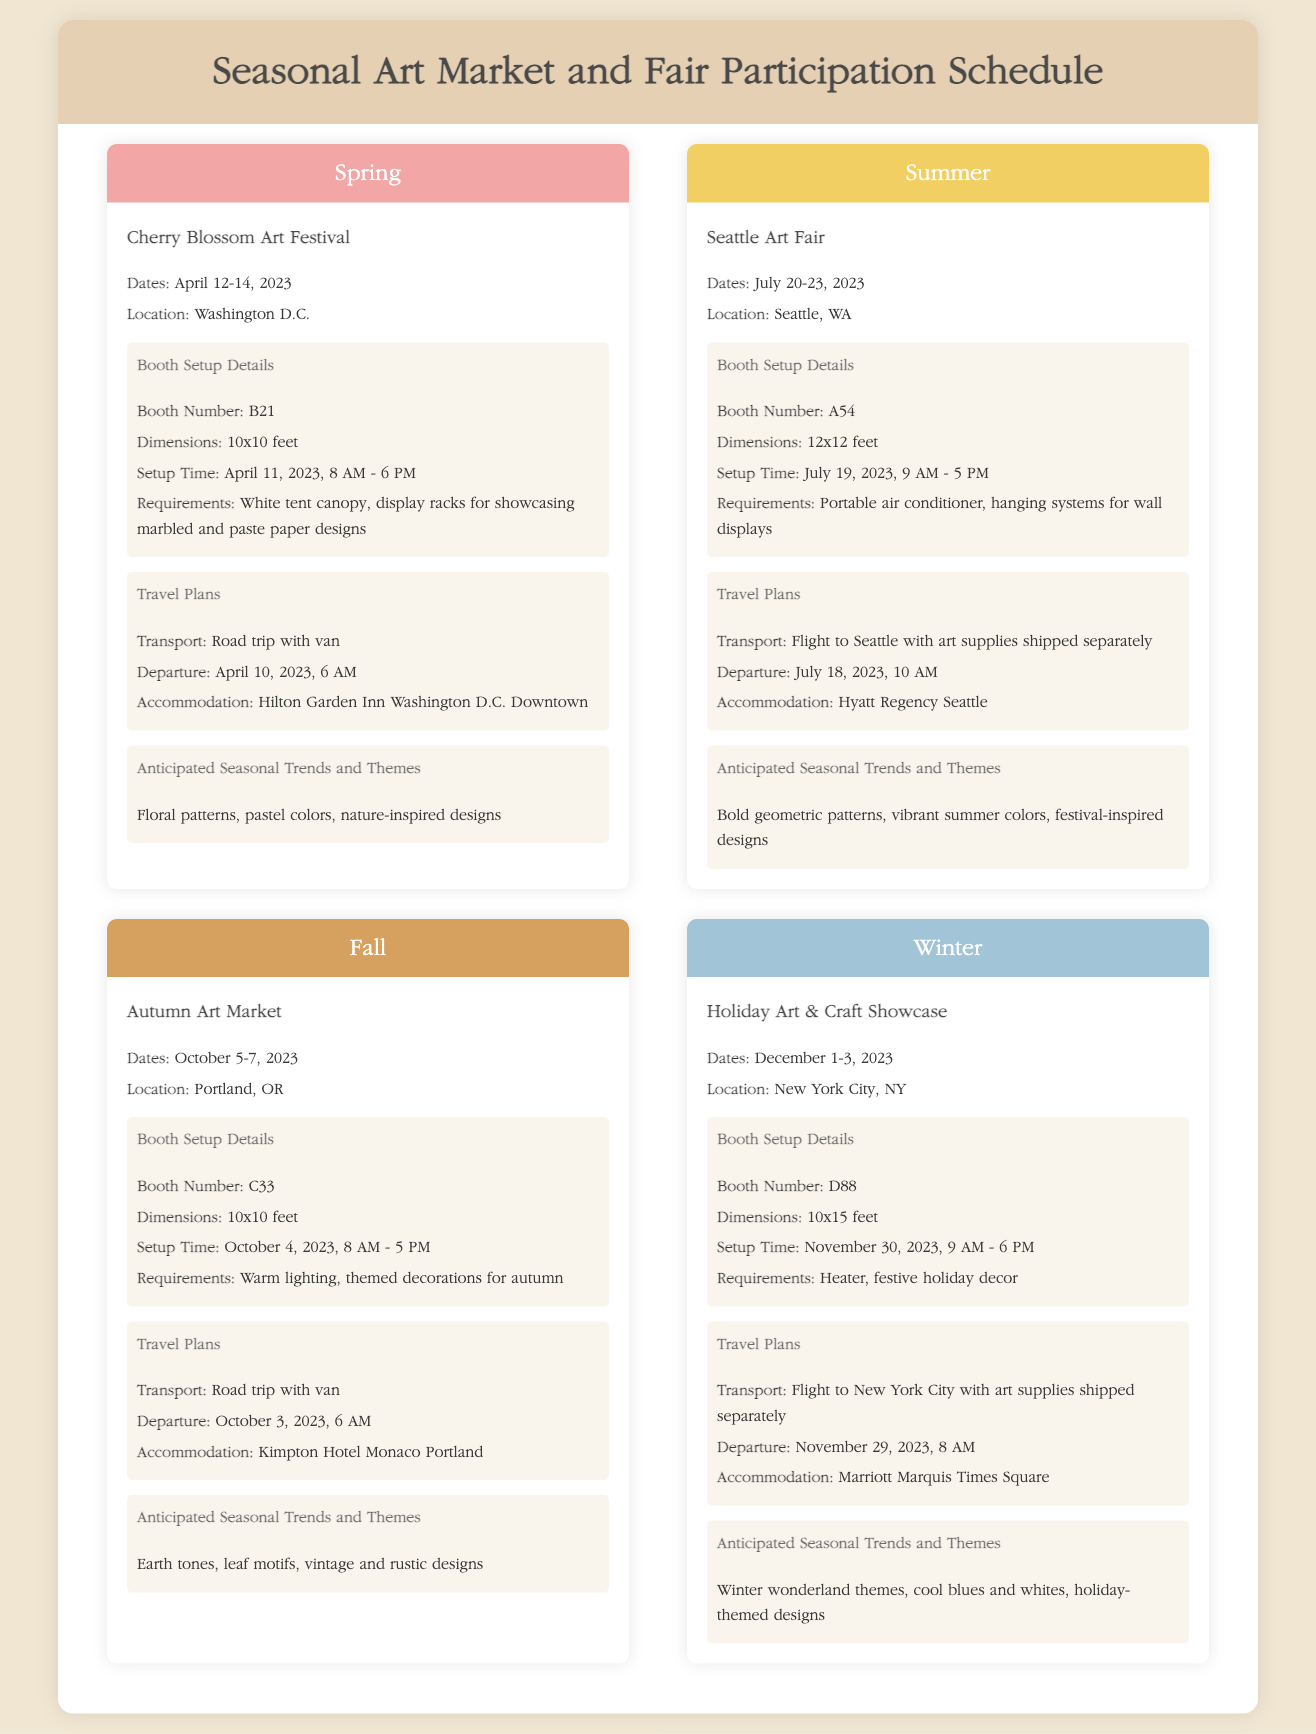What are the dates of the Cherry Blossom Art Festival? The dates are explicitly stated in the document for the event, which is April 12-14, 2023.
Answer: April 12-14, 2023 What is the booth number for the Holiday Art & Craft Showcase? The booth number is clearly mentioned in the details section for this specific event, which is D88.
Answer: D88 What is the location of the Autumn Art Market? The location is provided in the event details for the Autumn Art Market, which is Portland, OR.
Answer: Portland, OR What are the anticipated trends for Summer? The anticipated trends are listed as bold geometric patterns, vibrant summer colors, festival-inspired designs.
Answer: Bold geometric patterns, vibrant summer colors, festival-inspired designs When is the booth setup for the Seattle Art Fair? The setup time is specified in the event details for the Seattle Art Fair, which is July 19, 2023, 9 AM - 5 PM.
Answer: July 19, 2023, 9 AM - 5 PM What transport method is planned for the travel to the Holiday Art & Craft Showcase? The transport method is mentioned under travel plans, which is flight to New York City with art supplies shipped separately.
Answer: Flight to New York City How long is the setup time for the Cherry Blossom Art Festival? Setup time is described in the booth setup details for this event, which is from April 11, 2023, 8 AM - 6 PM.
Answer: April 11, 2023, 8 AM - 6 PM What is the accommodation for the Autumn Art Market? The accommodation is stated in the travel plans section for this event, which is Kimpton Hotel Monaco Portland.
Answer: Kimpton Hotel Monaco Portland What is the booth dimension for the Holiday Art & Craft Showcase? The booth dimensions are specified in the booth setup section, which states 10x15 feet.
Answer: 10x15 feet 